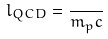<formula> <loc_0><loc_0><loc_500><loc_500>l _ { Q C D } = { \frac { } { m _ { p } c } }</formula> 